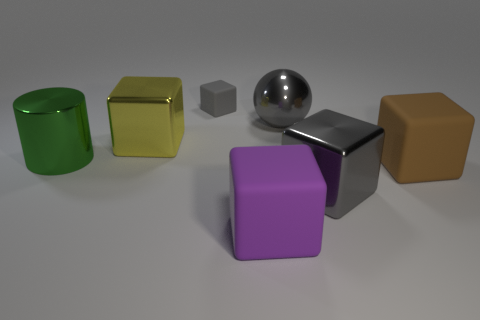What is the color of the big cylinder that is made of the same material as the big gray ball?
Make the answer very short. Green. What number of other yellow things have the same material as the large yellow object?
Provide a short and direct response. 0. There is a large cylinder; is its color the same as the large metal cube behind the large green metal cylinder?
Your answer should be very brief. No. What color is the large metallic block on the left side of the gray block right of the big metal sphere?
Provide a succinct answer. Yellow. There is a cylinder that is the same size as the brown rubber thing; what is its color?
Give a very brief answer. Green. Are there any large brown objects that have the same shape as the purple matte thing?
Offer a terse response. Yes. What is the shape of the large purple rubber thing?
Provide a succinct answer. Cube. Are there more metal cylinders that are left of the big green cylinder than small cubes in front of the big yellow metal object?
Ensure brevity in your answer.  No. What number of other objects are the same size as the purple object?
Ensure brevity in your answer.  5. There is a large object that is both behind the big metallic cylinder and to the left of the big ball; what is it made of?
Provide a short and direct response. Metal. 